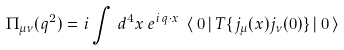Convert formula to latex. <formula><loc_0><loc_0><loc_500><loc_500>\Pi _ { \mu \nu } ( q ^ { 2 } ) = i \int \, d ^ { 4 } x \, e ^ { i \, q \cdot x } \ \langle \, 0 \, | \, T \{ j _ { \mu } ( x ) j _ { \nu } ( 0 ) \} \, | \, 0 \, \rangle</formula> 